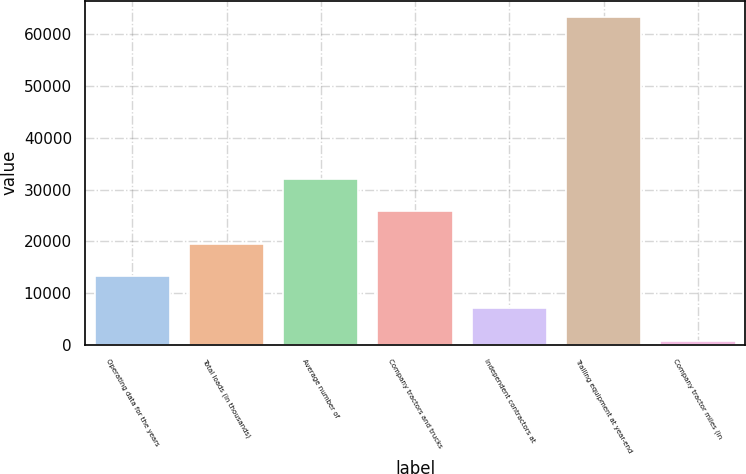Convert chart to OTSL. <chart><loc_0><loc_0><loc_500><loc_500><bar_chart><fcel>Operating data for the years<fcel>Total loads (in thousands)<fcel>Average number of<fcel>Company tractors and trucks<fcel>Independent contractors at<fcel>Trailing equipment at year-end<fcel>Company tractor miles (in<nl><fcel>13299.2<fcel>19550.3<fcel>32052.5<fcel>25801.4<fcel>7048.1<fcel>63308<fcel>797<nl></chart> 